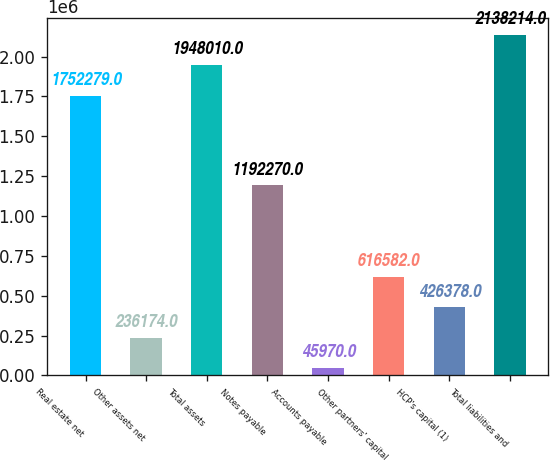Convert chart to OTSL. <chart><loc_0><loc_0><loc_500><loc_500><bar_chart><fcel>Real estate net<fcel>Other assets net<fcel>Total assets<fcel>Notes payable<fcel>Accounts payable<fcel>Other partners' capital<fcel>HCP's capital (1)<fcel>Total liabilities and<nl><fcel>1.75228e+06<fcel>236174<fcel>1.94801e+06<fcel>1.19227e+06<fcel>45970<fcel>616582<fcel>426378<fcel>2.13821e+06<nl></chart> 